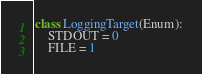Convert code to text. <code><loc_0><loc_0><loc_500><loc_500><_Python_>

class LoggingTarget(Enum):
    STDOUT = 0
    FILE = 1
</code> 